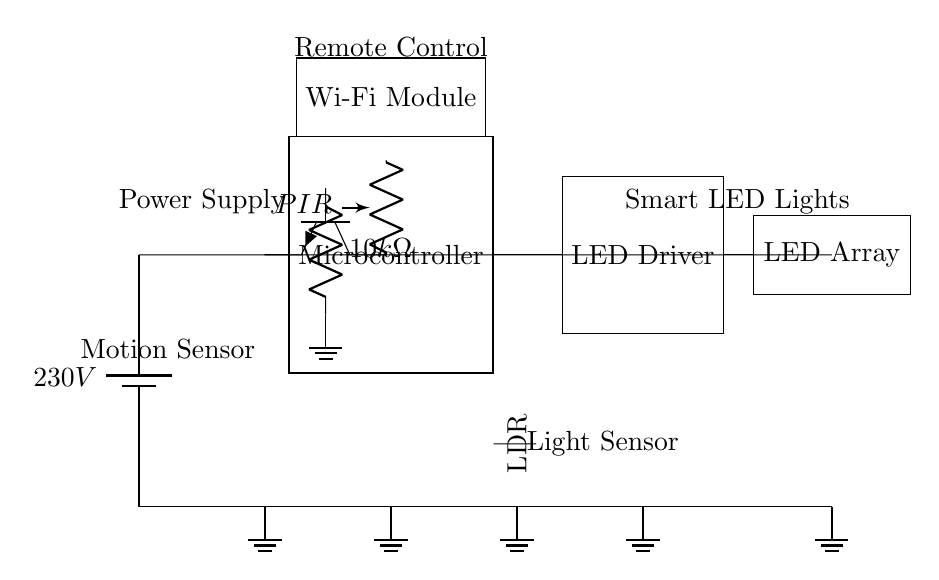What is the main power supply voltage? The circuit diagram indicates that the main power supply voltage is 230V, which is labeled on the battery symbol in the diagram.
Answer: 230V What component is used to detect motion? The circuit contains a motion sensor, specifically identified as a PIR (Passive Infrared) sensor, which is labeled just before the microcontroller.
Answer: PIR How many components are used for controlling lighting? The diagram shows two components specifically labeled for controlling lighting: the LED Driver and the LED Array. Thus, the total is two.
Answer: 2 What does the light sensor type in the circuit represent? The light sensor in the circuit is represented by an LDR (Light Dependent Resistor), which is designed to detect ambient light levels and is labeled next to the microcontroller.
Answer: LDR How is the microcontroller powered in this circuit? The microcontroller is connected to the main power supply via direct wiring from the battery, meaning it receives power directly from the 230V supply.
Answer: Directly from the battery What is the function of the Wi-Fi Module in this circuit? The Wi-Fi Module provides remote control capabilities, allowing for wireless communication and control of the lighting system, as indicated by its position and label above the microcontroller.
Answer: Remote control What might happen when the motion sensor detects no movement? If no movement is detected by the PIR sensor, the microcontroller likely turns the LED lights off to enhance energy efficiency, indicating a programmed response to save energy.
Answer: Turns off the LED lights 